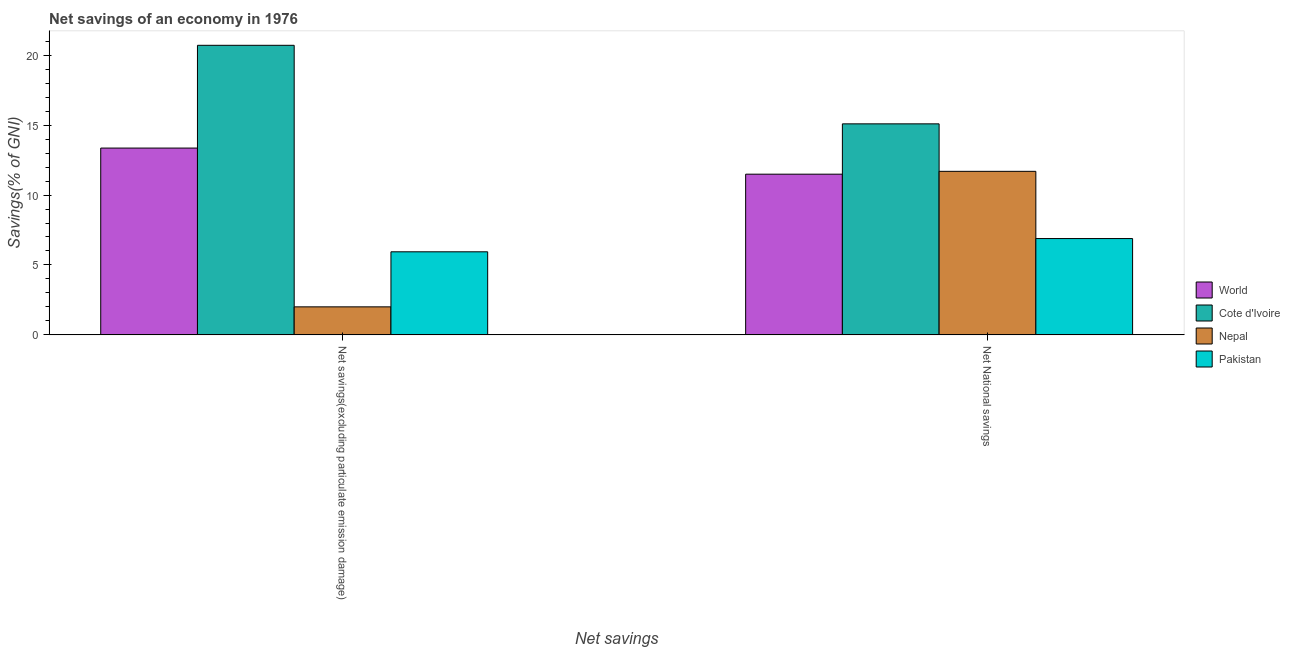How many different coloured bars are there?
Provide a short and direct response. 4. How many groups of bars are there?
Keep it short and to the point. 2. Are the number of bars per tick equal to the number of legend labels?
Make the answer very short. Yes. Are the number of bars on each tick of the X-axis equal?
Ensure brevity in your answer.  Yes. How many bars are there on the 1st tick from the right?
Give a very brief answer. 4. What is the label of the 2nd group of bars from the left?
Your answer should be compact. Net National savings. What is the net national savings in World?
Your answer should be very brief. 11.49. Across all countries, what is the maximum net savings(excluding particulate emission damage)?
Keep it short and to the point. 20.71. Across all countries, what is the minimum net savings(excluding particulate emission damage)?
Your response must be concise. 2.01. In which country was the net savings(excluding particulate emission damage) maximum?
Provide a succinct answer. Cote d'Ivoire. In which country was the net national savings minimum?
Ensure brevity in your answer.  Pakistan. What is the total net national savings in the graph?
Give a very brief answer. 45.17. What is the difference between the net national savings in Pakistan and that in Cote d'Ivoire?
Your answer should be very brief. -8.2. What is the difference between the net national savings in Cote d'Ivoire and the net savings(excluding particulate emission damage) in World?
Ensure brevity in your answer.  1.73. What is the average net national savings per country?
Your response must be concise. 11.29. What is the difference between the net savings(excluding particulate emission damage) and net national savings in Nepal?
Provide a succinct answer. -9.69. In how many countries, is the net national savings greater than 18 %?
Keep it short and to the point. 0. What is the ratio of the net national savings in World to that in Nepal?
Make the answer very short. 0.98. Is the net national savings in World less than that in Cote d'Ivoire?
Your answer should be very brief. Yes. What does the 4th bar from the left in Net savings(excluding particulate emission damage) represents?
Your answer should be compact. Pakistan. What does the 2nd bar from the right in Net savings(excluding particulate emission damage) represents?
Offer a terse response. Nepal. How many bars are there?
Provide a succinct answer. 8. Are all the bars in the graph horizontal?
Your answer should be very brief. No. What is the difference between two consecutive major ticks on the Y-axis?
Keep it short and to the point. 5. How many legend labels are there?
Your answer should be very brief. 4. What is the title of the graph?
Your response must be concise. Net savings of an economy in 1976. What is the label or title of the X-axis?
Provide a succinct answer. Net savings. What is the label or title of the Y-axis?
Offer a terse response. Savings(% of GNI). What is the Savings(% of GNI) in World in Net savings(excluding particulate emission damage)?
Ensure brevity in your answer.  13.36. What is the Savings(% of GNI) of Cote d'Ivoire in Net savings(excluding particulate emission damage)?
Ensure brevity in your answer.  20.71. What is the Savings(% of GNI) of Nepal in Net savings(excluding particulate emission damage)?
Make the answer very short. 2.01. What is the Savings(% of GNI) in Pakistan in Net savings(excluding particulate emission damage)?
Give a very brief answer. 5.94. What is the Savings(% of GNI) of World in Net National savings?
Your answer should be very brief. 11.49. What is the Savings(% of GNI) of Cote d'Ivoire in Net National savings?
Provide a succinct answer. 15.09. What is the Savings(% of GNI) in Nepal in Net National savings?
Your answer should be very brief. 11.7. What is the Savings(% of GNI) of Pakistan in Net National savings?
Provide a short and direct response. 6.89. Across all Net savings, what is the maximum Savings(% of GNI) in World?
Give a very brief answer. 13.36. Across all Net savings, what is the maximum Savings(% of GNI) in Cote d'Ivoire?
Your answer should be very brief. 20.71. Across all Net savings, what is the maximum Savings(% of GNI) of Nepal?
Keep it short and to the point. 11.7. Across all Net savings, what is the maximum Savings(% of GNI) of Pakistan?
Provide a short and direct response. 6.89. Across all Net savings, what is the minimum Savings(% of GNI) of World?
Your answer should be compact. 11.49. Across all Net savings, what is the minimum Savings(% of GNI) of Cote d'Ivoire?
Your answer should be very brief. 15.09. Across all Net savings, what is the minimum Savings(% of GNI) of Nepal?
Give a very brief answer. 2.01. Across all Net savings, what is the minimum Savings(% of GNI) of Pakistan?
Keep it short and to the point. 5.94. What is the total Savings(% of GNI) of World in the graph?
Provide a short and direct response. 24.85. What is the total Savings(% of GNI) in Cote d'Ivoire in the graph?
Ensure brevity in your answer.  35.8. What is the total Savings(% of GNI) in Nepal in the graph?
Make the answer very short. 13.7. What is the total Savings(% of GNI) in Pakistan in the graph?
Keep it short and to the point. 12.83. What is the difference between the Savings(% of GNI) of World in Net savings(excluding particulate emission damage) and that in Net National savings?
Your answer should be compact. 1.87. What is the difference between the Savings(% of GNI) of Cote d'Ivoire in Net savings(excluding particulate emission damage) and that in Net National savings?
Your answer should be very brief. 5.62. What is the difference between the Savings(% of GNI) in Nepal in Net savings(excluding particulate emission damage) and that in Net National savings?
Your answer should be very brief. -9.69. What is the difference between the Savings(% of GNI) of Pakistan in Net savings(excluding particulate emission damage) and that in Net National savings?
Give a very brief answer. -0.95. What is the difference between the Savings(% of GNI) in World in Net savings(excluding particulate emission damage) and the Savings(% of GNI) in Cote d'Ivoire in Net National savings?
Your answer should be very brief. -1.73. What is the difference between the Savings(% of GNI) of World in Net savings(excluding particulate emission damage) and the Savings(% of GNI) of Nepal in Net National savings?
Your answer should be compact. 1.66. What is the difference between the Savings(% of GNI) in World in Net savings(excluding particulate emission damage) and the Savings(% of GNI) in Pakistan in Net National savings?
Make the answer very short. 6.47. What is the difference between the Savings(% of GNI) in Cote d'Ivoire in Net savings(excluding particulate emission damage) and the Savings(% of GNI) in Nepal in Net National savings?
Offer a terse response. 9.01. What is the difference between the Savings(% of GNI) in Cote d'Ivoire in Net savings(excluding particulate emission damage) and the Savings(% of GNI) in Pakistan in Net National savings?
Keep it short and to the point. 13.82. What is the difference between the Savings(% of GNI) in Nepal in Net savings(excluding particulate emission damage) and the Savings(% of GNI) in Pakistan in Net National savings?
Your response must be concise. -4.88. What is the average Savings(% of GNI) in World per Net savings?
Offer a very short reply. 12.43. What is the average Savings(% of GNI) of Cote d'Ivoire per Net savings?
Your answer should be compact. 17.9. What is the average Savings(% of GNI) of Nepal per Net savings?
Provide a short and direct response. 6.85. What is the average Savings(% of GNI) of Pakistan per Net savings?
Keep it short and to the point. 6.42. What is the difference between the Savings(% of GNI) of World and Savings(% of GNI) of Cote d'Ivoire in Net savings(excluding particulate emission damage)?
Offer a very short reply. -7.35. What is the difference between the Savings(% of GNI) in World and Savings(% of GNI) in Nepal in Net savings(excluding particulate emission damage)?
Offer a very short reply. 11.35. What is the difference between the Savings(% of GNI) of World and Savings(% of GNI) of Pakistan in Net savings(excluding particulate emission damage)?
Give a very brief answer. 7.42. What is the difference between the Savings(% of GNI) of Cote d'Ivoire and Savings(% of GNI) of Nepal in Net savings(excluding particulate emission damage)?
Offer a very short reply. 18.7. What is the difference between the Savings(% of GNI) of Cote d'Ivoire and Savings(% of GNI) of Pakistan in Net savings(excluding particulate emission damage)?
Give a very brief answer. 14.77. What is the difference between the Savings(% of GNI) of Nepal and Savings(% of GNI) of Pakistan in Net savings(excluding particulate emission damage)?
Your answer should be compact. -3.94. What is the difference between the Savings(% of GNI) in World and Savings(% of GNI) in Cote d'Ivoire in Net National savings?
Offer a terse response. -3.6. What is the difference between the Savings(% of GNI) of World and Savings(% of GNI) of Nepal in Net National savings?
Give a very brief answer. -0.2. What is the difference between the Savings(% of GNI) of World and Savings(% of GNI) of Pakistan in Net National savings?
Offer a very short reply. 4.6. What is the difference between the Savings(% of GNI) of Cote d'Ivoire and Savings(% of GNI) of Nepal in Net National savings?
Make the answer very short. 3.39. What is the difference between the Savings(% of GNI) of Cote d'Ivoire and Savings(% of GNI) of Pakistan in Net National savings?
Offer a terse response. 8.2. What is the difference between the Savings(% of GNI) in Nepal and Savings(% of GNI) in Pakistan in Net National savings?
Offer a very short reply. 4.81. What is the ratio of the Savings(% of GNI) in World in Net savings(excluding particulate emission damage) to that in Net National savings?
Your answer should be compact. 1.16. What is the ratio of the Savings(% of GNI) of Cote d'Ivoire in Net savings(excluding particulate emission damage) to that in Net National savings?
Keep it short and to the point. 1.37. What is the ratio of the Savings(% of GNI) in Nepal in Net savings(excluding particulate emission damage) to that in Net National savings?
Ensure brevity in your answer.  0.17. What is the ratio of the Savings(% of GNI) of Pakistan in Net savings(excluding particulate emission damage) to that in Net National savings?
Make the answer very short. 0.86. What is the difference between the highest and the second highest Savings(% of GNI) in World?
Provide a succinct answer. 1.87. What is the difference between the highest and the second highest Savings(% of GNI) of Cote d'Ivoire?
Your answer should be compact. 5.62. What is the difference between the highest and the second highest Savings(% of GNI) of Nepal?
Provide a succinct answer. 9.69. What is the difference between the highest and the second highest Savings(% of GNI) in Pakistan?
Your response must be concise. 0.95. What is the difference between the highest and the lowest Savings(% of GNI) in World?
Your answer should be very brief. 1.87. What is the difference between the highest and the lowest Savings(% of GNI) in Cote d'Ivoire?
Make the answer very short. 5.62. What is the difference between the highest and the lowest Savings(% of GNI) of Nepal?
Offer a very short reply. 9.69. What is the difference between the highest and the lowest Savings(% of GNI) of Pakistan?
Give a very brief answer. 0.95. 